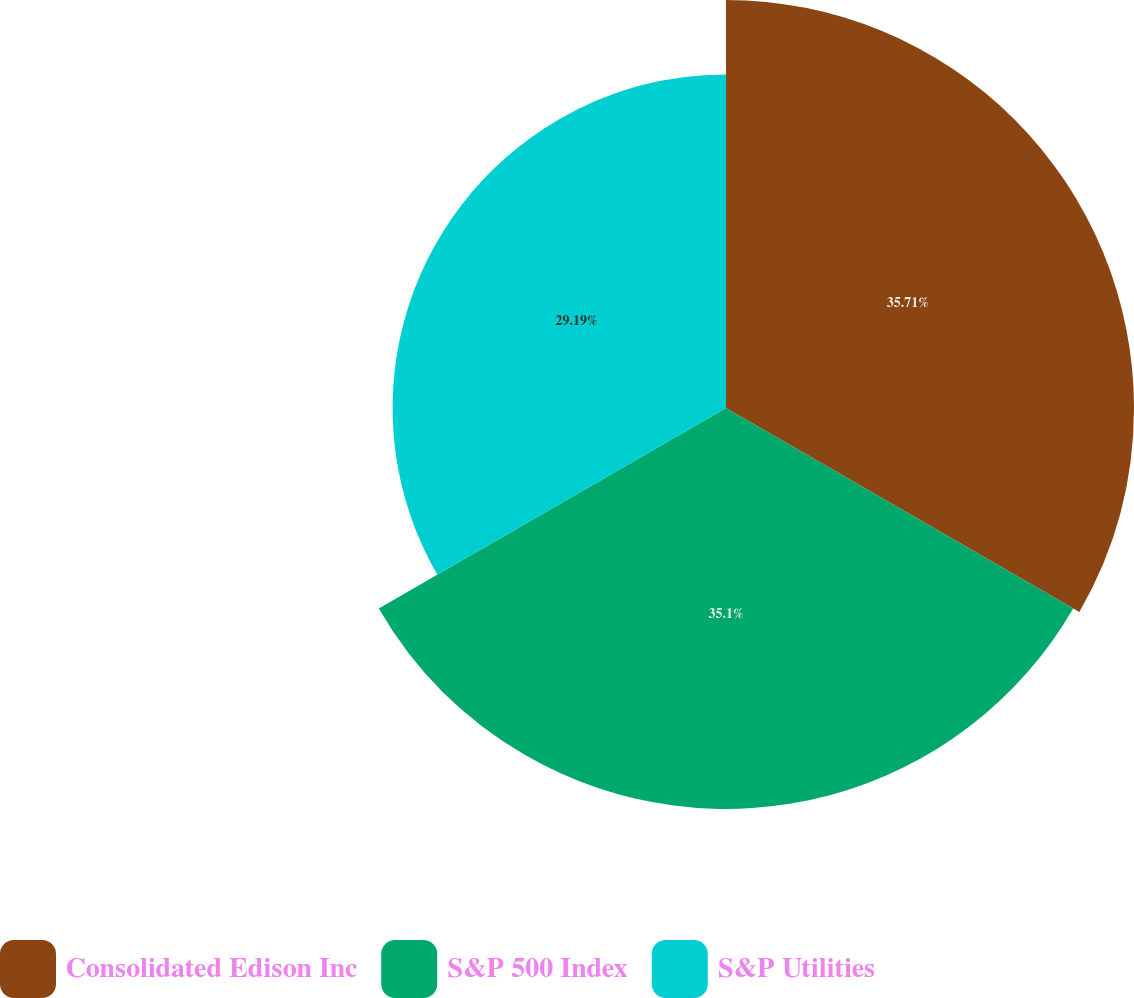<chart> <loc_0><loc_0><loc_500><loc_500><pie_chart><fcel>Consolidated Edison Inc<fcel>S&P 500 Index<fcel>S&P Utilities<nl><fcel>35.72%<fcel>35.1%<fcel>29.19%<nl></chart> 